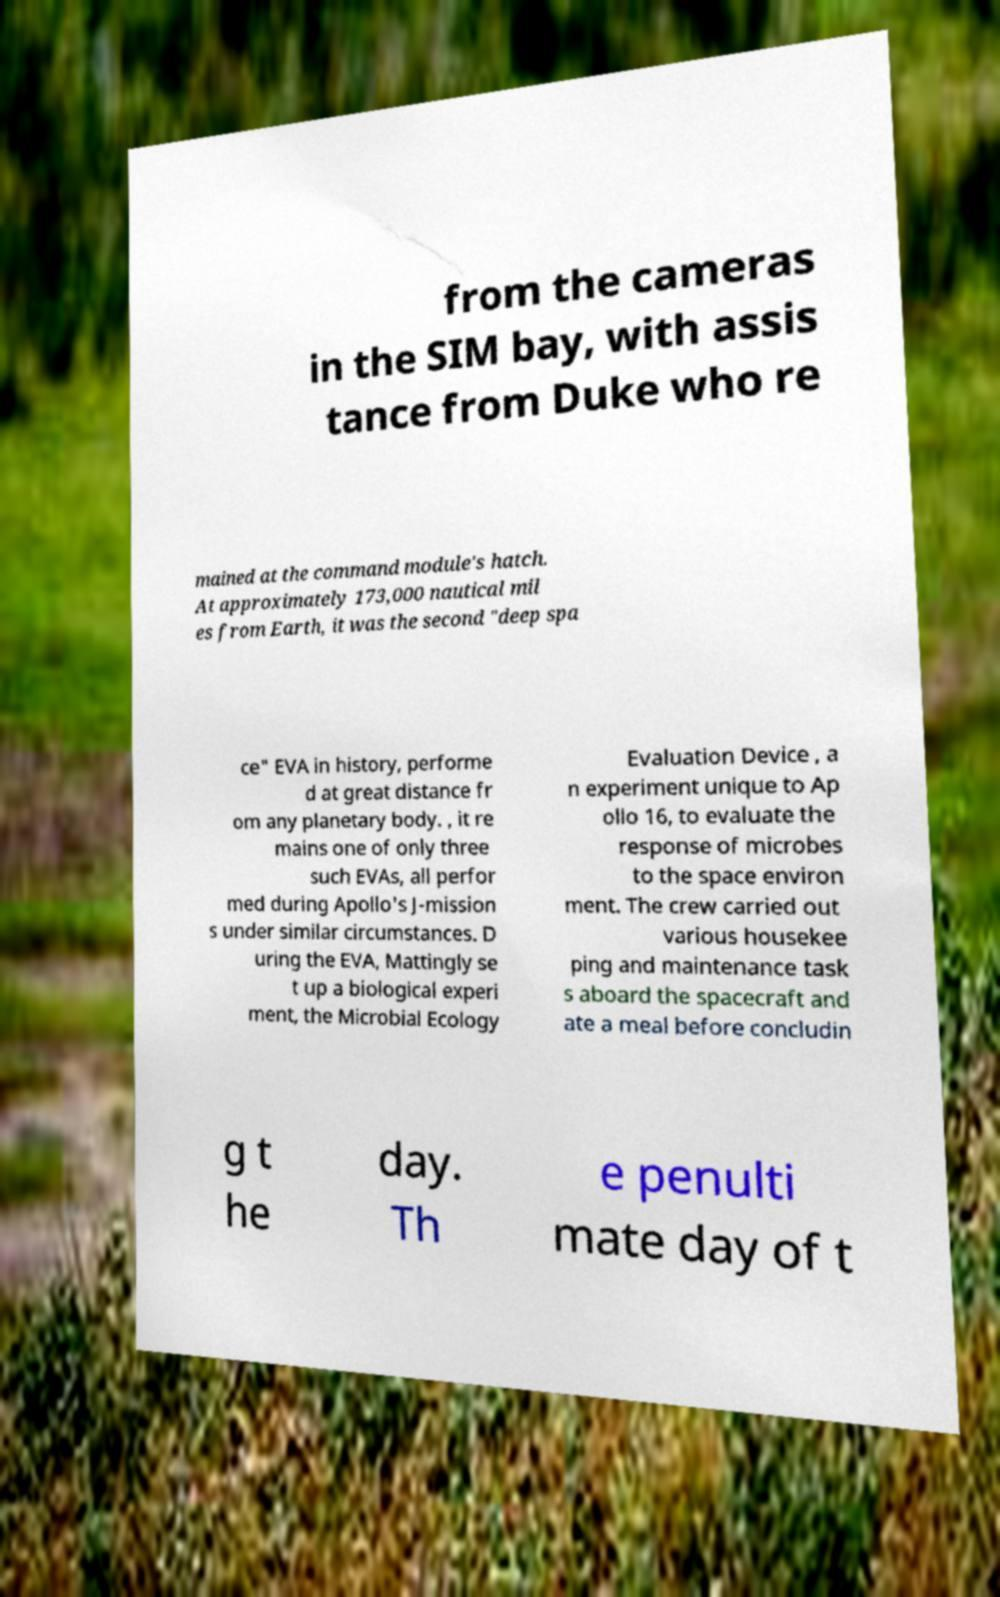What messages or text are displayed in this image? I need them in a readable, typed format. from the cameras in the SIM bay, with assis tance from Duke who re mained at the command module's hatch. At approximately 173,000 nautical mil es from Earth, it was the second "deep spa ce" EVA in history, performe d at great distance fr om any planetary body. , it re mains one of only three such EVAs, all perfor med during Apollo's J-mission s under similar circumstances. D uring the EVA, Mattingly se t up a biological experi ment, the Microbial Ecology Evaluation Device , a n experiment unique to Ap ollo 16, to evaluate the response of microbes to the space environ ment. The crew carried out various housekee ping and maintenance task s aboard the spacecraft and ate a meal before concludin g t he day. Th e penulti mate day of t 